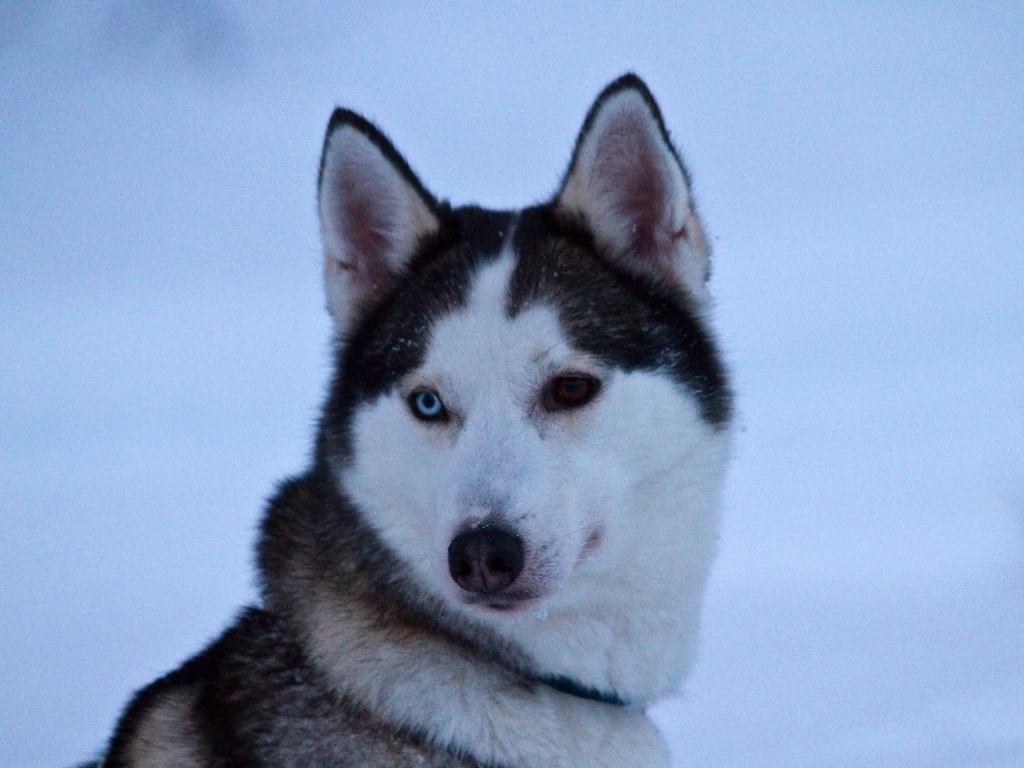Is this type of dog suitable for warm climates? Siberian Huskies are bred for cold environments, so they can struggle with heat if not properly cared for. In warmer climates, they require sufficient shade, air conditioning, and plenty of water. It's also important to manage their exercise in the cooler parts of the day and to be cautious of overheating. 